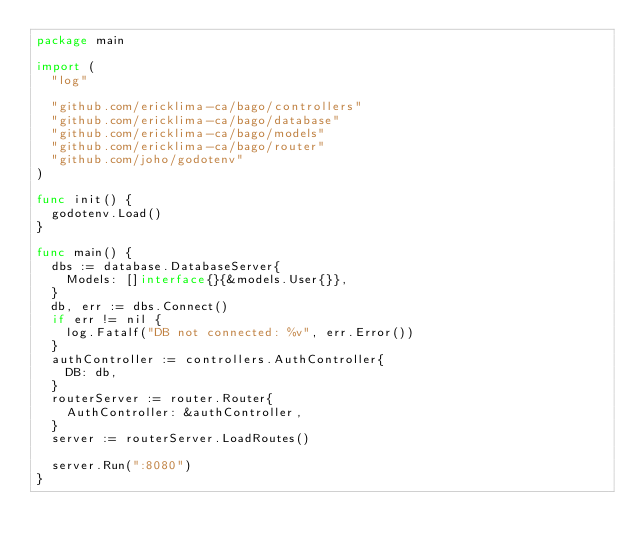<code> <loc_0><loc_0><loc_500><loc_500><_Go_>package main

import (
	"log"

	"github.com/ericklima-ca/bago/controllers"
	"github.com/ericklima-ca/bago/database"
	"github.com/ericklima-ca/bago/models"
	"github.com/ericklima-ca/bago/router"
	"github.com/joho/godotenv"
)

func init() {
	godotenv.Load()
}

func main() {
	dbs := database.DatabaseServer{
		Models: []interface{}{&models.User{}},
	}
	db, err := dbs.Connect()
	if err != nil {
		log.Fatalf("DB not connected: %v", err.Error())
	}
	authController := controllers.AuthController{
		DB: db,
	}
	routerServer := router.Router{
		AuthController: &authController,
	}
	server := routerServer.LoadRoutes()

	server.Run(":8080")
}
</code> 